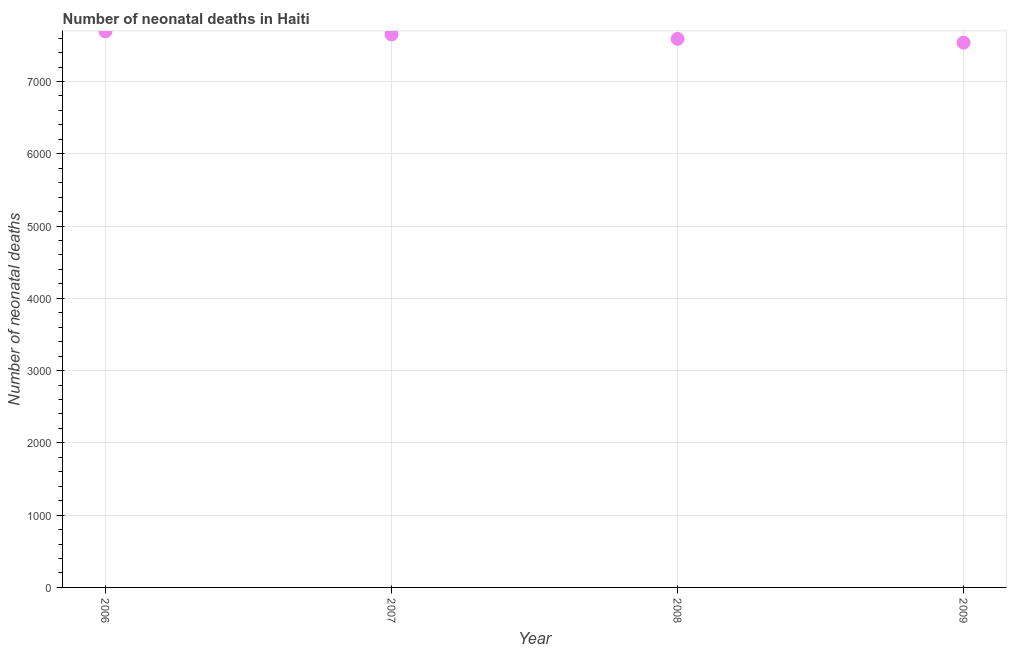What is the number of neonatal deaths in 2008?
Make the answer very short. 7590. Across all years, what is the maximum number of neonatal deaths?
Keep it short and to the point. 7693. Across all years, what is the minimum number of neonatal deaths?
Your answer should be very brief. 7537. In which year was the number of neonatal deaths maximum?
Your answer should be compact. 2006. In which year was the number of neonatal deaths minimum?
Your response must be concise. 2009. What is the sum of the number of neonatal deaths?
Your answer should be very brief. 3.05e+04. What is the difference between the number of neonatal deaths in 2007 and 2009?
Ensure brevity in your answer.  114. What is the average number of neonatal deaths per year?
Provide a succinct answer. 7617.75. What is the median number of neonatal deaths?
Your answer should be very brief. 7620.5. In how many years, is the number of neonatal deaths greater than 5000 ?
Your response must be concise. 4. Do a majority of the years between 2009 and 2008 (inclusive) have number of neonatal deaths greater than 600 ?
Keep it short and to the point. No. What is the ratio of the number of neonatal deaths in 2008 to that in 2009?
Ensure brevity in your answer.  1.01. Is the number of neonatal deaths in 2006 less than that in 2007?
Provide a succinct answer. No. What is the difference between the highest and the second highest number of neonatal deaths?
Keep it short and to the point. 42. What is the difference between the highest and the lowest number of neonatal deaths?
Your response must be concise. 156. In how many years, is the number of neonatal deaths greater than the average number of neonatal deaths taken over all years?
Ensure brevity in your answer.  2. What is the difference between two consecutive major ticks on the Y-axis?
Offer a terse response. 1000. Does the graph contain any zero values?
Make the answer very short. No. Does the graph contain grids?
Ensure brevity in your answer.  Yes. What is the title of the graph?
Keep it short and to the point. Number of neonatal deaths in Haiti. What is the label or title of the X-axis?
Give a very brief answer. Year. What is the label or title of the Y-axis?
Offer a terse response. Number of neonatal deaths. What is the Number of neonatal deaths in 2006?
Give a very brief answer. 7693. What is the Number of neonatal deaths in 2007?
Offer a very short reply. 7651. What is the Number of neonatal deaths in 2008?
Your answer should be very brief. 7590. What is the Number of neonatal deaths in 2009?
Ensure brevity in your answer.  7537. What is the difference between the Number of neonatal deaths in 2006 and 2007?
Keep it short and to the point. 42. What is the difference between the Number of neonatal deaths in 2006 and 2008?
Provide a short and direct response. 103. What is the difference between the Number of neonatal deaths in 2006 and 2009?
Ensure brevity in your answer.  156. What is the difference between the Number of neonatal deaths in 2007 and 2008?
Make the answer very short. 61. What is the difference between the Number of neonatal deaths in 2007 and 2009?
Keep it short and to the point. 114. What is the difference between the Number of neonatal deaths in 2008 and 2009?
Your answer should be compact. 53. What is the ratio of the Number of neonatal deaths in 2006 to that in 2008?
Offer a very short reply. 1.01. What is the ratio of the Number of neonatal deaths in 2007 to that in 2009?
Ensure brevity in your answer.  1.01. 